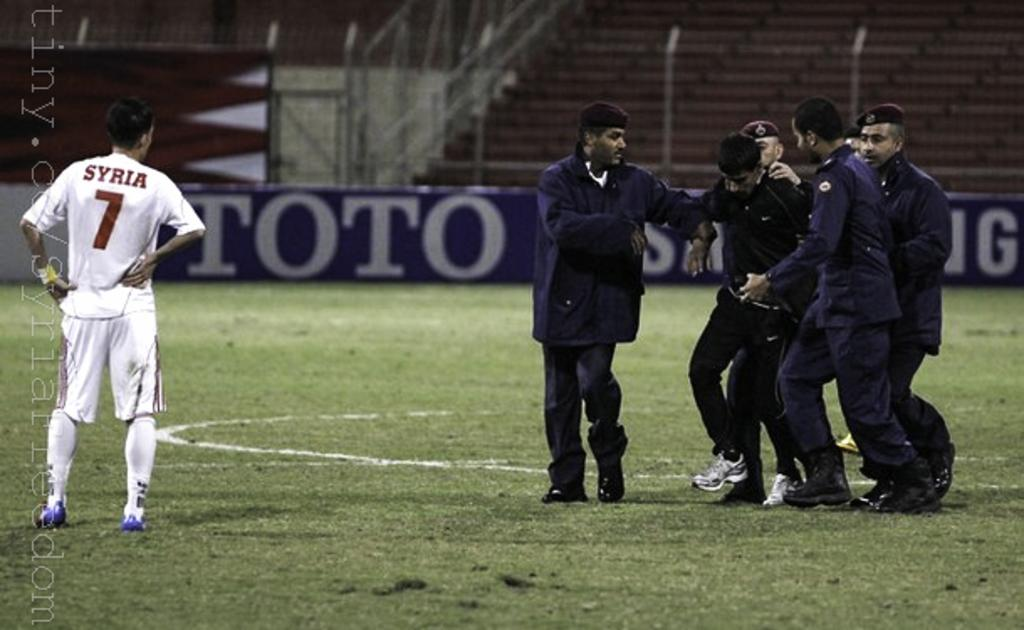Provide a one-sentence caption for the provided image. A soccer player with the number 7 on his shirt. 